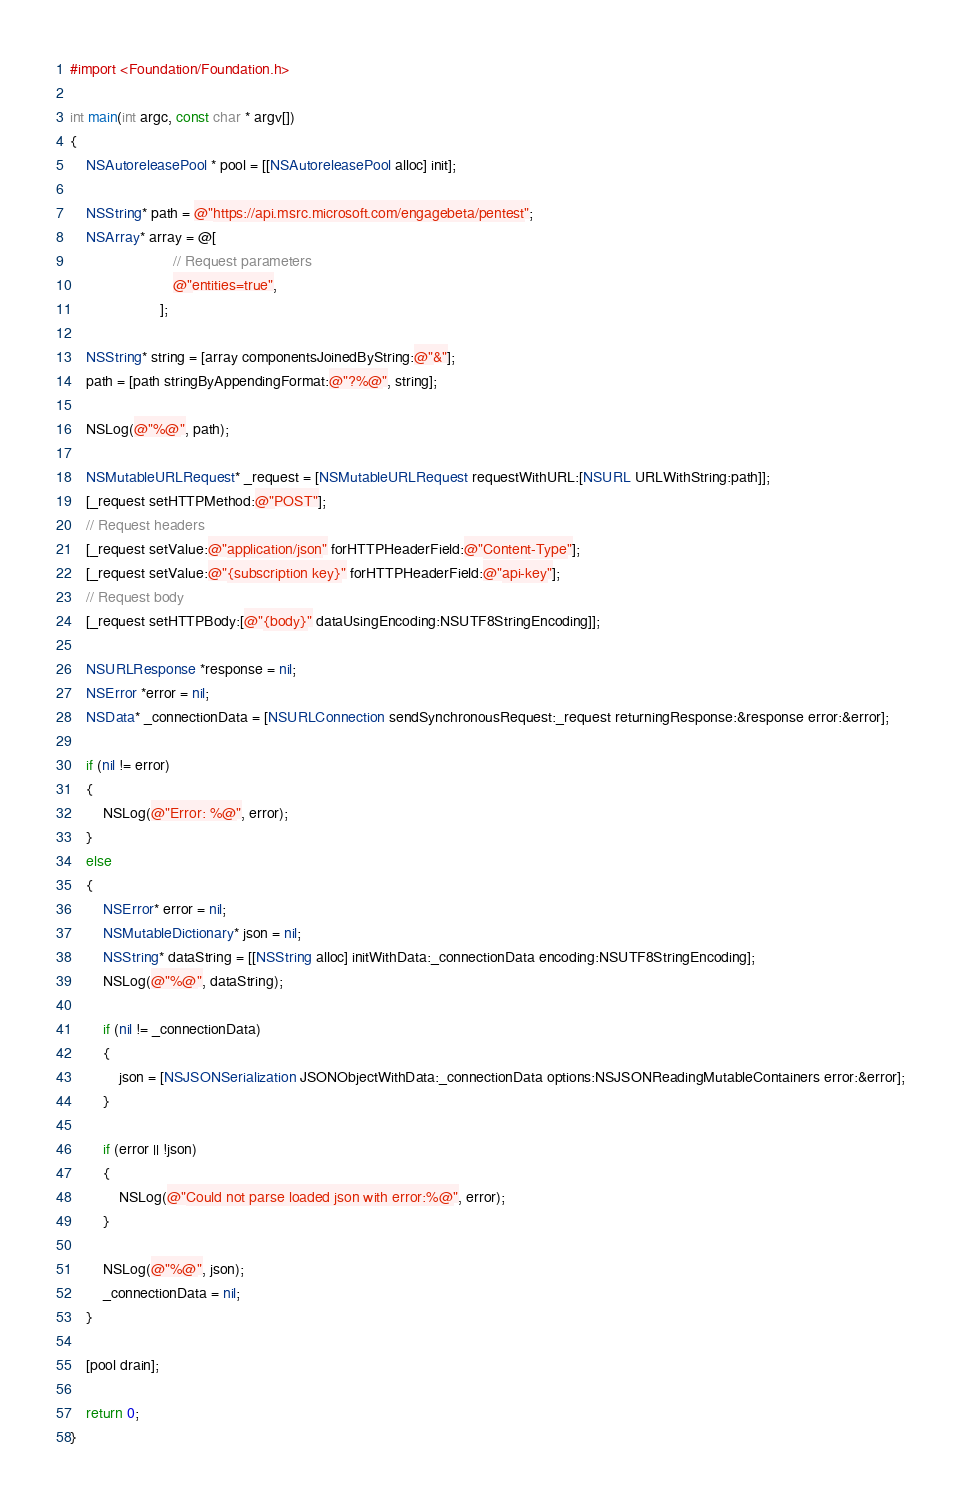Convert code to text. <code><loc_0><loc_0><loc_500><loc_500><_ObjectiveC_>#import <Foundation/Foundation.h>

int main(int argc, const char * argv[])
{
    NSAutoreleasePool * pool = [[NSAutoreleasePool alloc] init];
    
    NSString* path = @"https://api.msrc.microsoft.com/engagebeta/pentest";
    NSArray* array = @[
                         // Request parameters
                         @"entities=true",
                      ];
    
    NSString* string = [array componentsJoinedByString:@"&"];
    path = [path stringByAppendingFormat:@"?%@", string];

    NSLog(@"%@", path);

    NSMutableURLRequest* _request = [NSMutableURLRequest requestWithURL:[NSURL URLWithString:path]];
    [_request setHTTPMethod:@"POST"];
    // Request headers
    [_request setValue:@"application/json" forHTTPHeaderField:@"Content-Type"];
    [_request setValue:@"{subscription key}" forHTTPHeaderField:@"api-key"];
    // Request body
    [_request setHTTPBody:[@"{body}" dataUsingEncoding:NSUTF8StringEncoding]];
    
    NSURLResponse *response = nil;
    NSError *error = nil;
    NSData* _connectionData = [NSURLConnection sendSynchronousRequest:_request returningResponse:&response error:&error];

    if (nil != error)
    {
        NSLog(@"Error: %@", error);
    }
    else
    {
        NSError* error = nil;
        NSMutableDictionary* json = nil;
        NSString* dataString = [[NSString alloc] initWithData:_connectionData encoding:NSUTF8StringEncoding];
        NSLog(@"%@", dataString);
        
        if (nil != _connectionData)
        {
            json = [NSJSONSerialization JSONObjectWithData:_connectionData options:NSJSONReadingMutableContainers error:&error];
        }
        
        if (error || !json)
        {
            NSLog(@"Could not parse loaded json with error:%@", error);
        }
        
        NSLog(@"%@", json);
        _connectionData = nil;
    }
    
    [pool drain];

    return 0;
}
</code> 